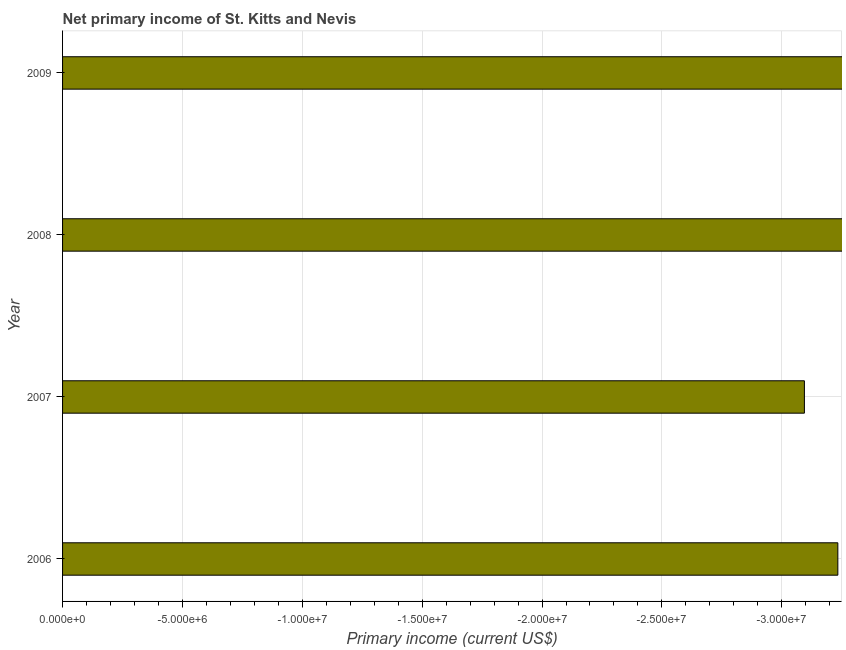What is the title of the graph?
Make the answer very short. Net primary income of St. Kitts and Nevis. What is the label or title of the X-axis?
Make the answer very short. Primary income (current US$). What is the label or title of the Y-axis?
Give a very brief answer. Year. Across all years, what is the minimum amount of primary income?
Offer a very short reply. 0. What is the sum of the amount of primary income?
Provide a succinct answer. 0. In how many years, is the amount of primary income greater than -27000000 US$?
Provide a short and direct response. 0. How many bars are there?
Ensure brevity in your answer.  0. How many years are there in the graph?
Your answer should be very brief. 4. What is the difference between two consecutive major ticks on the X-axis?
Offer a terse response. 5.00e+06. Are the values on the major ticks of X-axis written in scientific E-notation?
Keep it short and to the point. Yes. What is the Primary income (current US$) of 2008?
Provide a succinct answer. 0. 